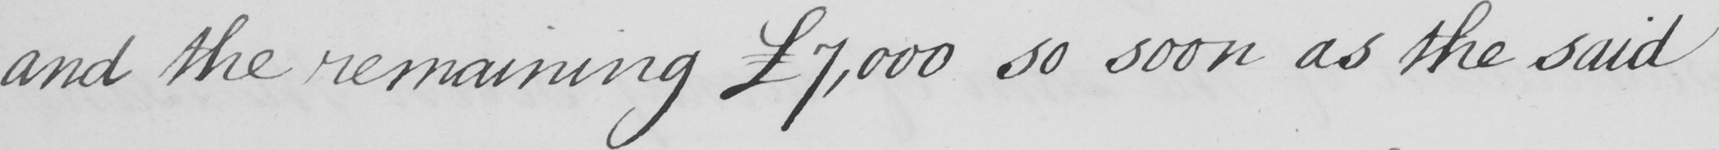Please transcribe the handwritten text in this image. and the remaining  £7,000 so soon as the said 